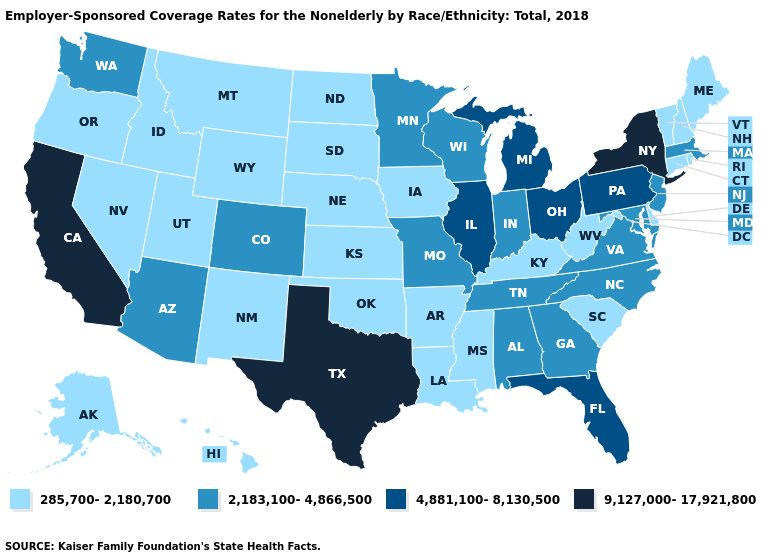Which states have the lowest value in the USA?
Short answer required. Alaska, Arkansas, Connecticut, Delaware, Hawaii, Idaho, Iowa, Kansas, Kentucky, Louisiana, Maine, Mississippi, Montana, Nebraska, Nevada, New Hampshire, New Mexico, North Dakota, Oklahoma, Oregon, Rhode Island, South Carolina, South Dakota, Utah, Vermont, West Virginia, Wyoming. How many symbols are there in the legend?
Concise answer only. 4. Name the states that have a value in the range 285,700-2,180,700?
Answer briefly. Alaska, Arkansas, Connecticut, Delaware, Hawaii, Idaho, Iowa, Kansas, Kentucky, Louisiana, Maine, Mississippi, Montana, Nebraska, Nevada, New Hampshire, New Mexico, North Dakota, Oklahoma, Oregon, Rhode Island, South Carolina, South Dakota, Utah, Vermont, West Virginia, Wyoming. What is the highest value in the MidWest ?
Short answer required. 4,881,100-8,130,500. What is the value of Georgia?
Quick response, please. 2,183,100-4,866,500. What is the value of Florida?
Write a very short answer. 4,881,100-8,130,500. Name the states that have a value in the range 9,127,000-17,921,800?
Write a very short answer. California, New York, Texas. What is the lowest value in the MidWest?
Keep it brief. 285,700-2,180,700. Name the states that have a value in the range 9,127,000-17,921,800?
Write a very short answer. California, New York, Texas. Name the states that have a value in the range 9,127,000-17,921,800?
Give a very brief answer. California, New York, Texas. Name the states that have a value in the range 9,127,000-17,921,800?
Quick response, please. California, New York, Texas. What is the value of Rhode Island?
Write a very short answer. 285,700-2,180,700. Does Texas have the same value as California?
Write a very short answer. Yes. What is the value of Connecticut?
Give a very brief answer. 285,700-2,180,700. What is the value of Hawaii?
Keep it brief. 285,700-2,180,700. 